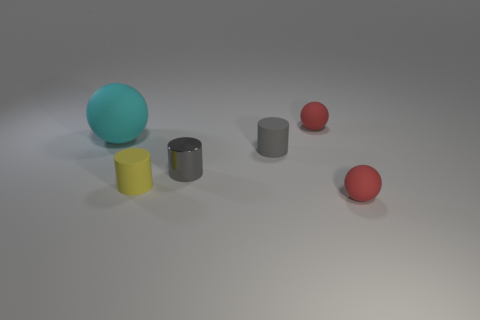Subtract all tiny red balls. How many balls are left? 1 Subtract all red spheres. How many spheres are left? 1 Add 2 cyan matte balls. How many cyan matte balls are left? 3 Add 2 small green metallic cylinders. How many small green metallic cylinders exist? 2 Add 4 tiny gray matte things. How many objects exist? 10 Subtract 0 green cylinders. How many objects are left? 6 Subtract 1 cylinders. How many cylinders are left? 2 Subtract all cyan spheres. Subtract all brown cubes. How many spheres are left? 2 Subtract all red blocks. How many red spheres are left? 2 Subtract all cyan shiny cylinders. Subtract all cyan rubber things. How many objects are left? 5 